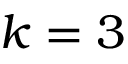<formula> <loc_0><loc_0><loc_500><loc_500>k = 3</formula> 